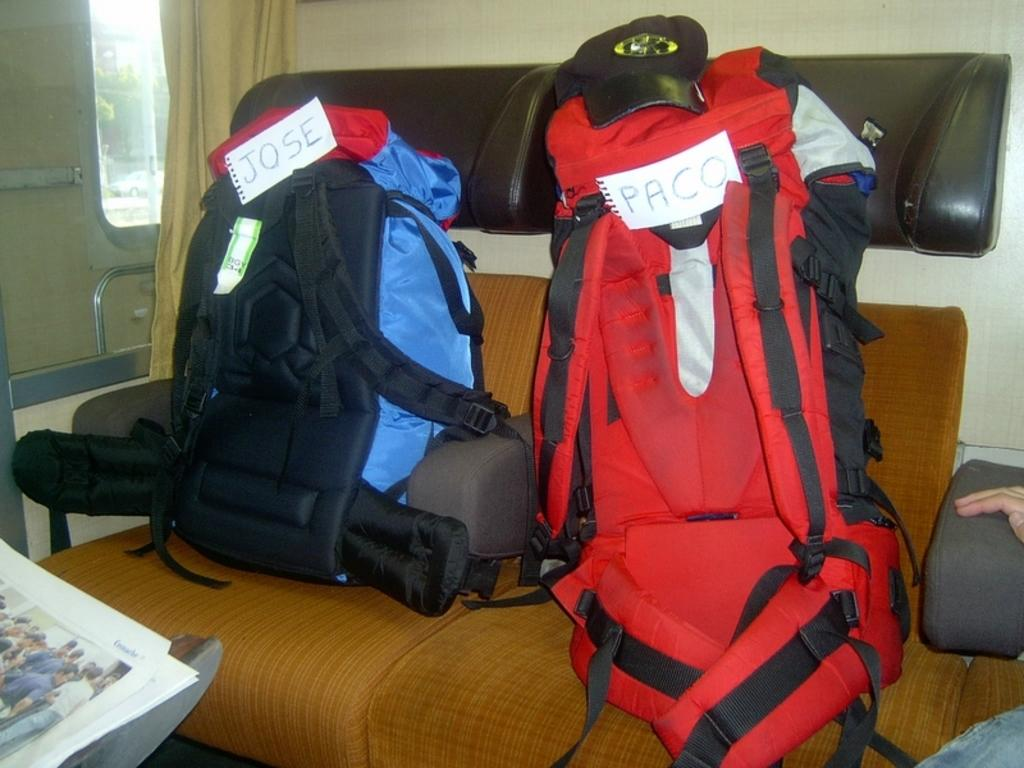<image>
Describe the image concisely. Two backpacks belong to people named Jose and Paco. 